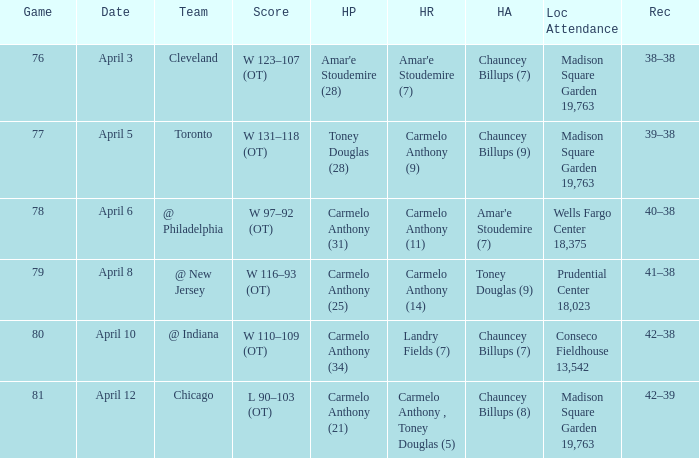Name the high assists for madison square garden 19,763 and record is 39–38 Chauncey Billups (9). 